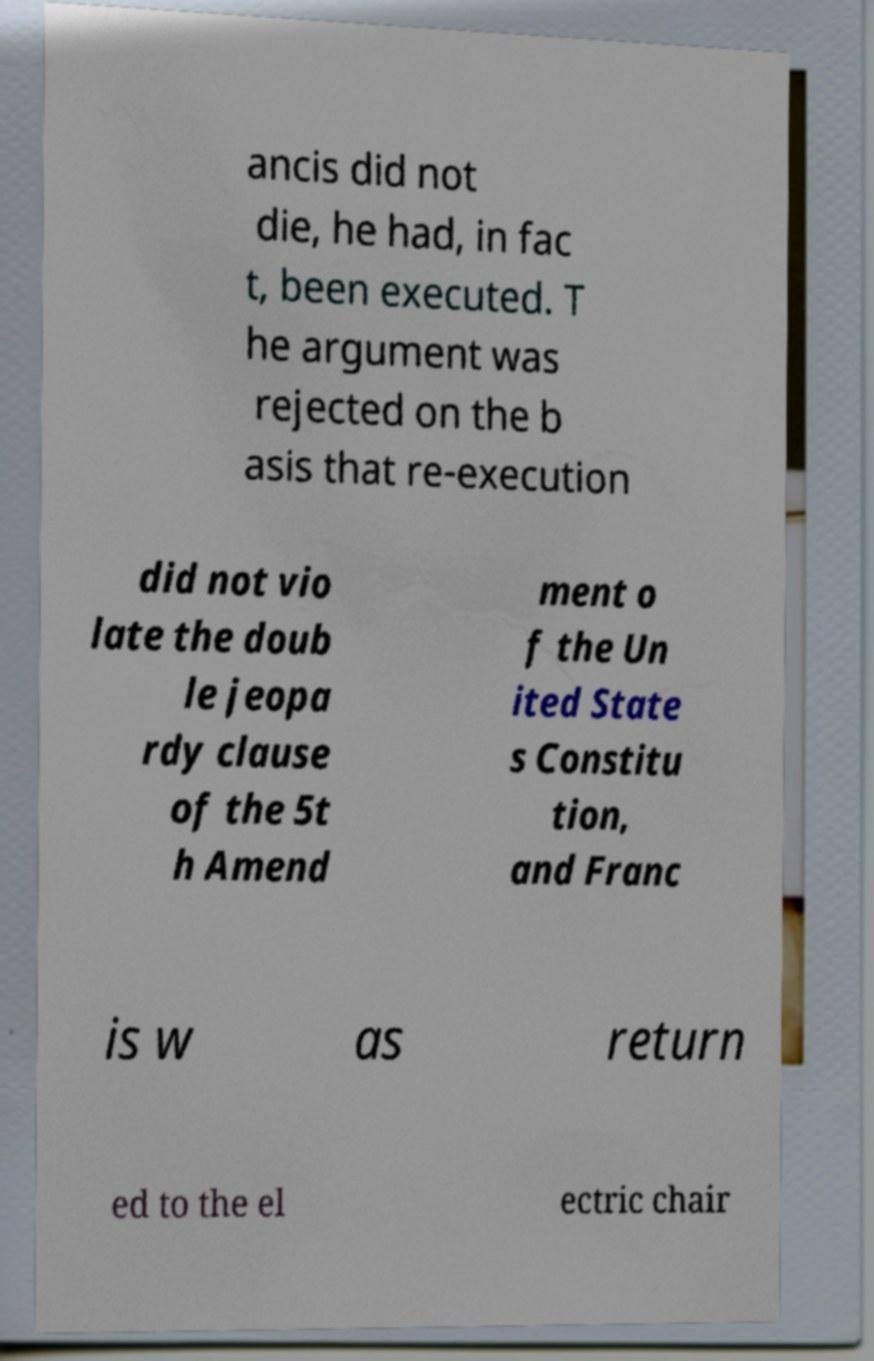There's text embedded in this image that I need extracted. Can you transcribe it verbatim? ancis did not die, he had, in fac t, been executed. T he argument was rejected on the b asis that re-execution did not vio late the doub le jeopa rdy clause of the 5t h Amend ment o f the Un ited State s Constitu tion, and Franc is w as return ed to the el ectric chair 